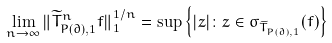Convert formula to latex. <formula><loc_0><loc_0><loc_500><loc_500>\lim _ { n \to \infty } \| { \widetilde { T } } _ { P ( \partial ) , 1 } ^ { n } f \| _ { 1 } ^ { 1 / n } = \sup \left \{ | z | \colon z \in \sigma _ { \widetilde { T } _ { P ( \partial ) , 1 } } ( f ) \right \}</formula> 